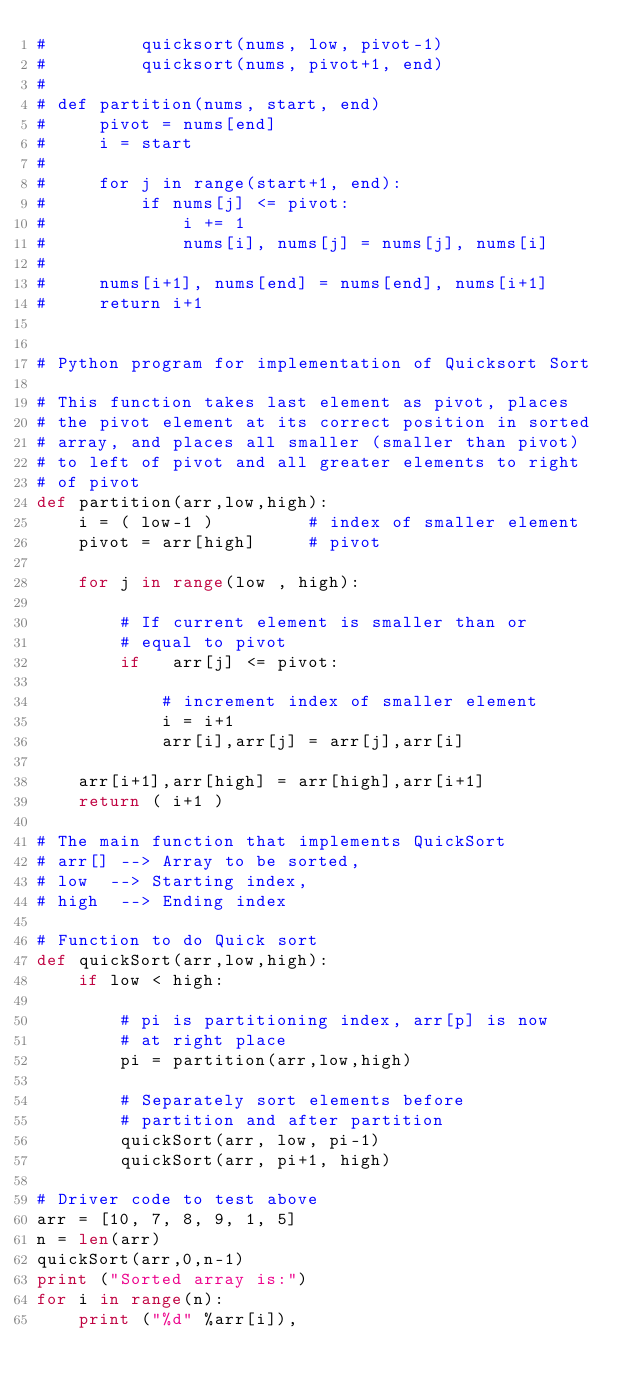<code> <loc_0><loc_0><loc_500><loc_500><_Python_>#         quicksort(nums, low, pivot-1)
#         quicksort(nums, pivot+1, end)
#
# def partition(nums, start, end)
#     pivot = nums[end]
#     i = start
#
#     for j in range(start+1, end):
#         if nums[j] <= pivot:
#             i += 1
#             nums[i], nums[j] = nums[j], nums[i]
#
#     nums[i+1], nums[end] = nums[end], nums[i+1]
#     return i+1


# Python program for implementation of Quicksort Sort

# This function takes last element as pivot, places
# the pivot element at its correct position in sorted
# array, and places all smaller (smaller than pivot)
# to left of pivot and all greater elements to right
# of pivot
def partition(arr,low,high):
    i = ( low-1 )         # index of smaller element
    pivot = arr[high]     # pivot

    for j in range(low , high):

        # If current element is smaller than or
        # equal to pivot
        if   arr[j] <= pivot:

            # increment index of smaller element
            i = i+1
            arr[i],arr[j] = arr[j],arr[i]

    arr[i+1],arr[high] = arr[high],arr[i+1]
    return ( i+1 )

# The main function that implements QuickSort
# arr[] --> Array to be sorted,
# low  --> Starting index,
# high  --> Ending index

# Function to do Quick sort
def quickSort(arr,low,high):
    if low < high:

        # pi is partitioning index, arr[p] is now
        # at right place
        pi = partition(arr,low,high)

        # Separately sort elements before
        # partition and after partition
        quickSort(arr, low, pi-1)
        quickSort(arr, pi+1, high)

# Driver code to test above
arr = [10, 7, 8, 9, 1, 5]
n = len(arr)
quickSort(arr,0,n-1)
print ("Sorted array is:")
for i in range(n):
    print ("%d" %arr[i]),
</code> 